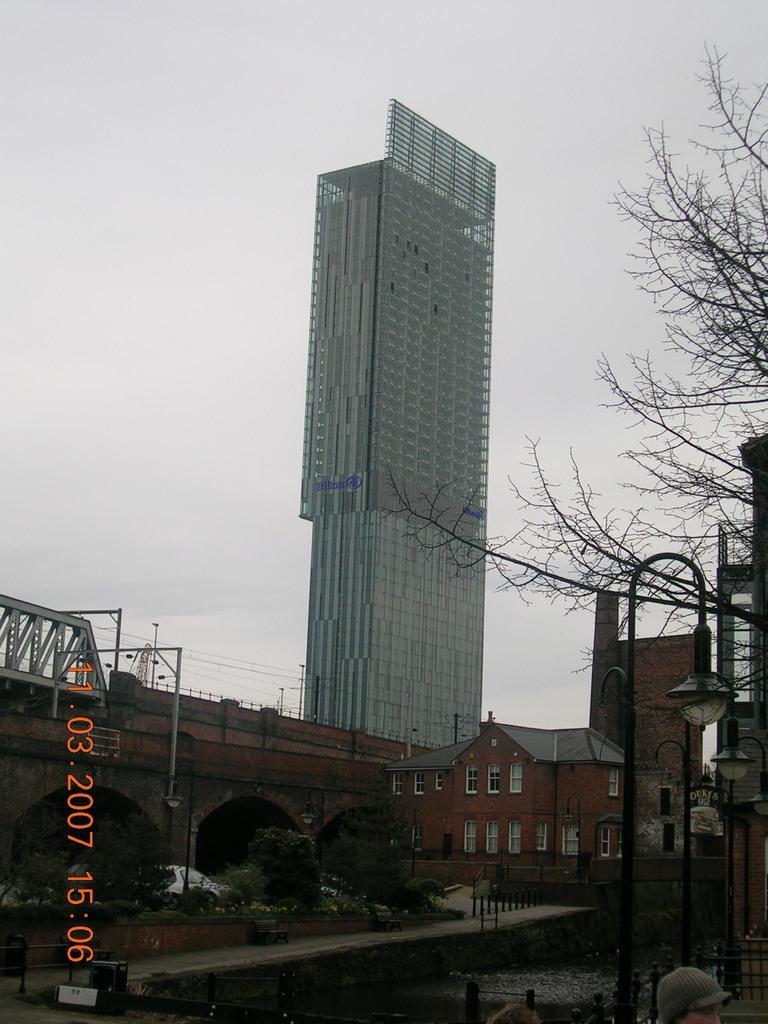How would you summarize this image in a sentence or two? This image is clicked on the road. Beside the road there are plants, a railing and grass on the ground. There are buildings in the image. To the right there are street light poles and trees. In the bottom right there is a head of a person. There is water in the image. At the top there is the sky. In the bottom left there are numbers on the image. 